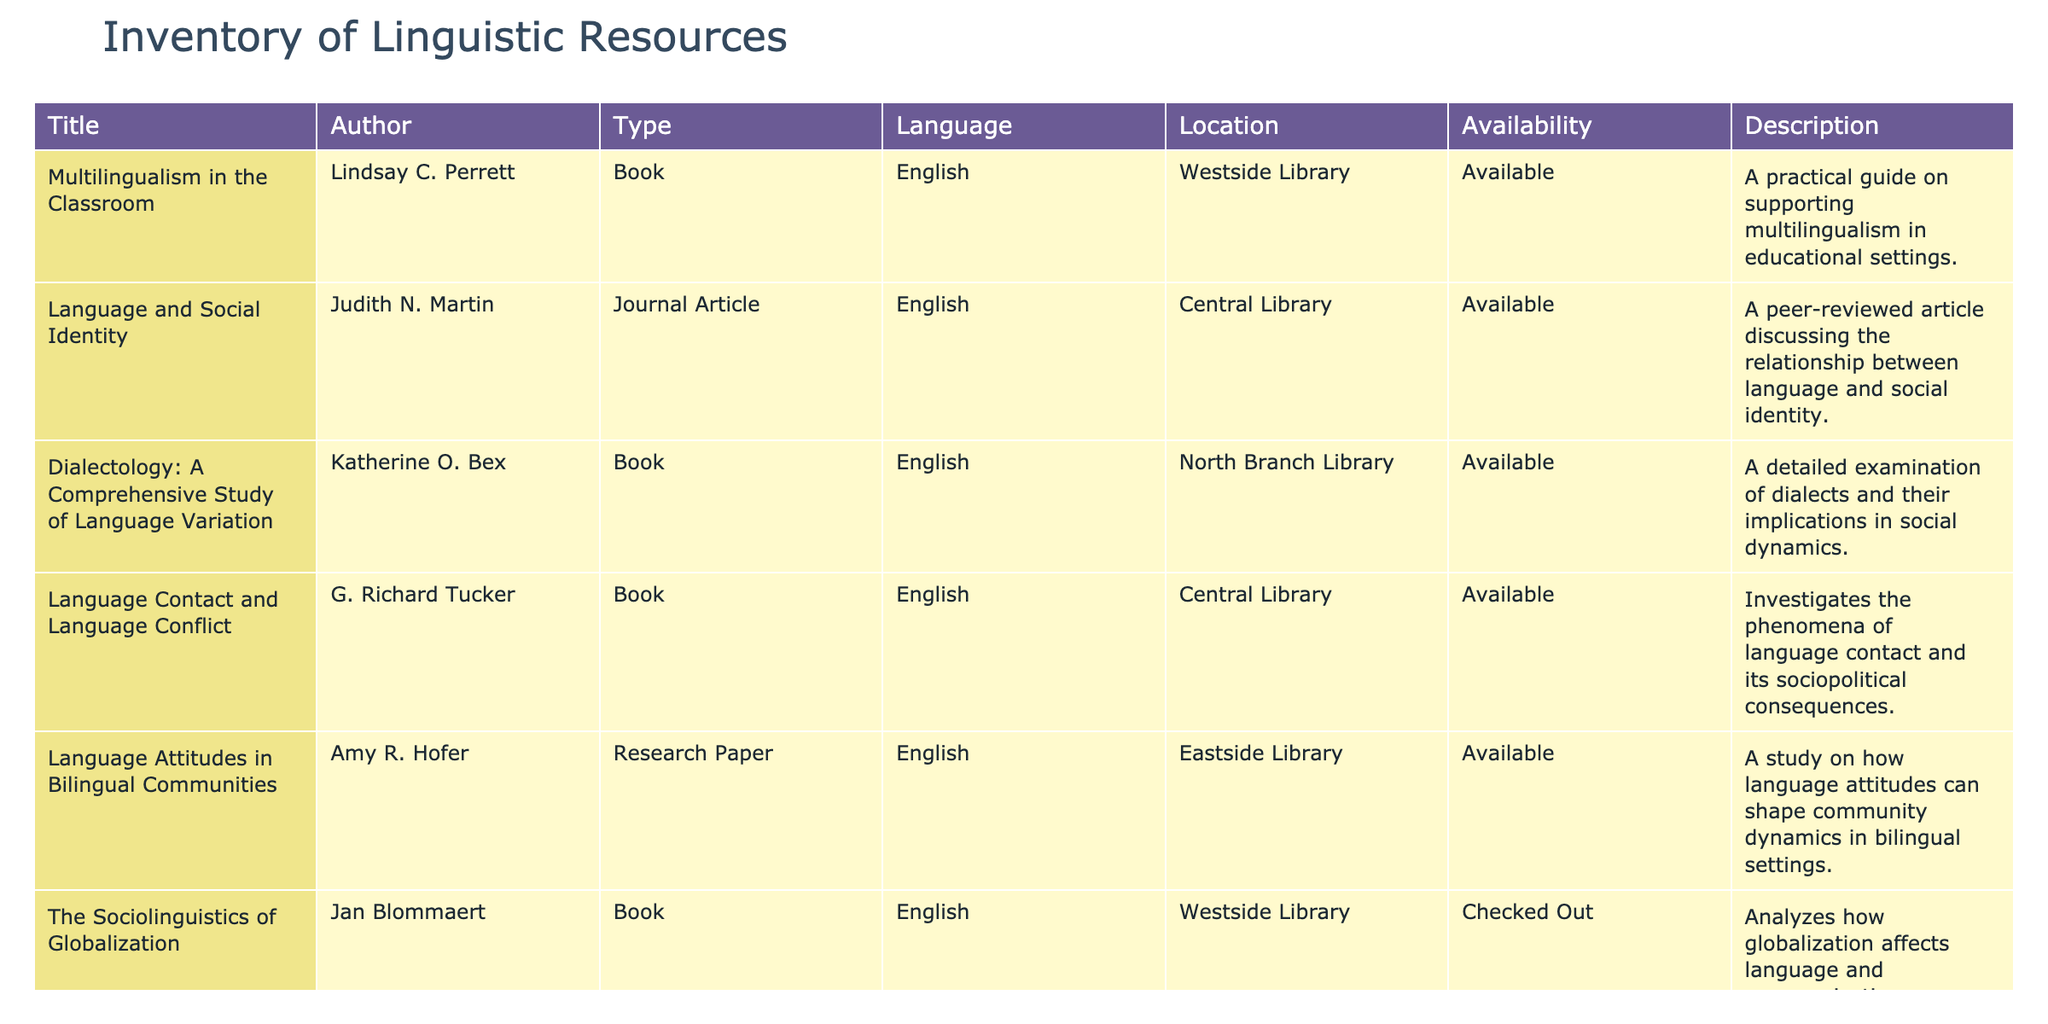What is the title of the book authored by Lindsay C. Perrett? The table lists the resources, and by checking the row where Lindsay C. Perrett is mentioned in the Author column, the corresponding title in the Title column is "Multilingualism in the Classroom."
Answer: "Multilingualism in the Classroom" Which resource is checked out at the Westside Library? By scanning the table, it is evident that "The Sociolinguistics of Globalization" is the only resource listed at the Westside Library that has the status "Checked Out."
Answer: "The Sociolinguistics of Globalization" How many books are available in English across all libraries? The books available in English, as seen in the table, are "Multilingualism in the Classroom," "Dialectology: A Comprehensive Study of Language Variation," "Language Contact and Language Conflict," and "The Sociolinguistics of Globalization." Therefore, there are a total of 4 books available.
Answer: 4 Is there any research paper available at the Eastside Library? Checking the table, there is one research paper titled "Language Attitudes in Bilingual Communities" by Amy R. Hofer, and it is marked as "Available," confirming that there is indeed a research paper at the Eastside Library.
Answer: Yes What is the difference between the number of books and journal articles available in the inventory? There are 4 books (the first four items) and 1 journal article (the second item) in the table. The difference is calculated as 4 - 1 = 3.
Answer: 3 How many total resources are available in the Central Library? The entries for the Central Library are "Language and Social Identity," "Language Contact and Language Conflict," and "The Sociolinguistics of Globalization." Among these, two are 'Available' and one is 'Checked Out,' leading to a total of 3 resources in the Central Library.
Answer: 3 What percentage of the total resources listed in the table are available? There are a total of 6 resources, of which 5 are marked as "Available." To find the percentage, calculate (5/6) * 100 = approximately 83.33%.
Answer: 83.33% Which author has written about language attitudes in bilingual settings? The table indicates that Amy R. Hofer is the author of the resource titled "Language Attitudes in Bilingual Communities," clearly addressing this topic.
Answer: Amy R. Hofer What common language do all the resources in this inventory share? By looking at the Language column, it is clear that all the listed resources are in English, making it the common language across this inventory.
Answer: English 